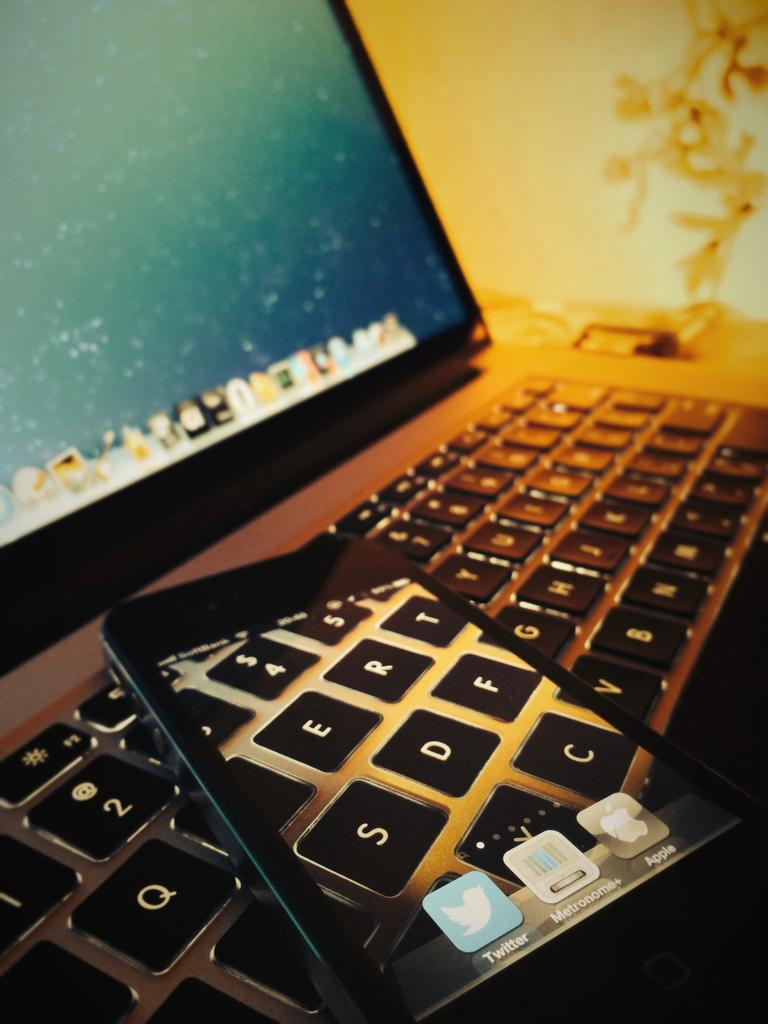What type of device is visible in the image? There is a monitor in the image. What other device is present in the image? There is a keyboard in the image. What might these devices be used for? These devices are typically used for inputting and displaying information, such as typing on the keyboard and viewing the output on the monitor. What type of prose can be seen on the monitor in the image? There is no prose visible on the monitor in the image; it is not displaying any text or written content. 